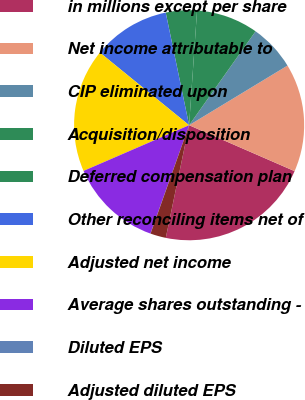Convert chart to OTSL. <chart><loc_0><loc_0><loc_500><loc_500><pie_chart><fcel>in millions except per share<fcel>Net income attributable to<fcel>CIP eliminated upon<fcel>Acquisition/disposition<fcel>Deferred compensation plan<fcel>Other reconciling items net of<fcel>Adjusted net income<fcel>Average shares outstanding -<fcel>Diluted EPS<fcel>Adjusted diluted EPS<nl><fcel>21.72%<fcel>15.21%<fcel>6.53%<fcel>8.7%<fcel>4.36%<fcel>10.87%<fcel>17.38%<fcel>13.04%<fcel>0.02%<fcel>2.19%<nl></chart> 